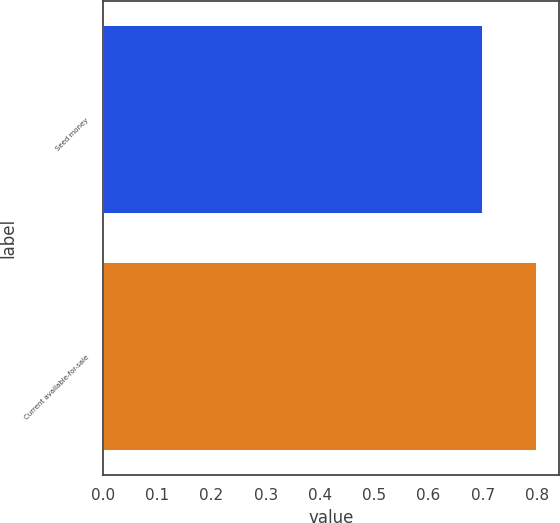<chart> <loc_0><loc_0><loc_500><loc_500><bar_chart><fcel>Seed money<fcel>Current available-for-sale<nl><fcel>0.7<fcel>0.8<nl></chart> 